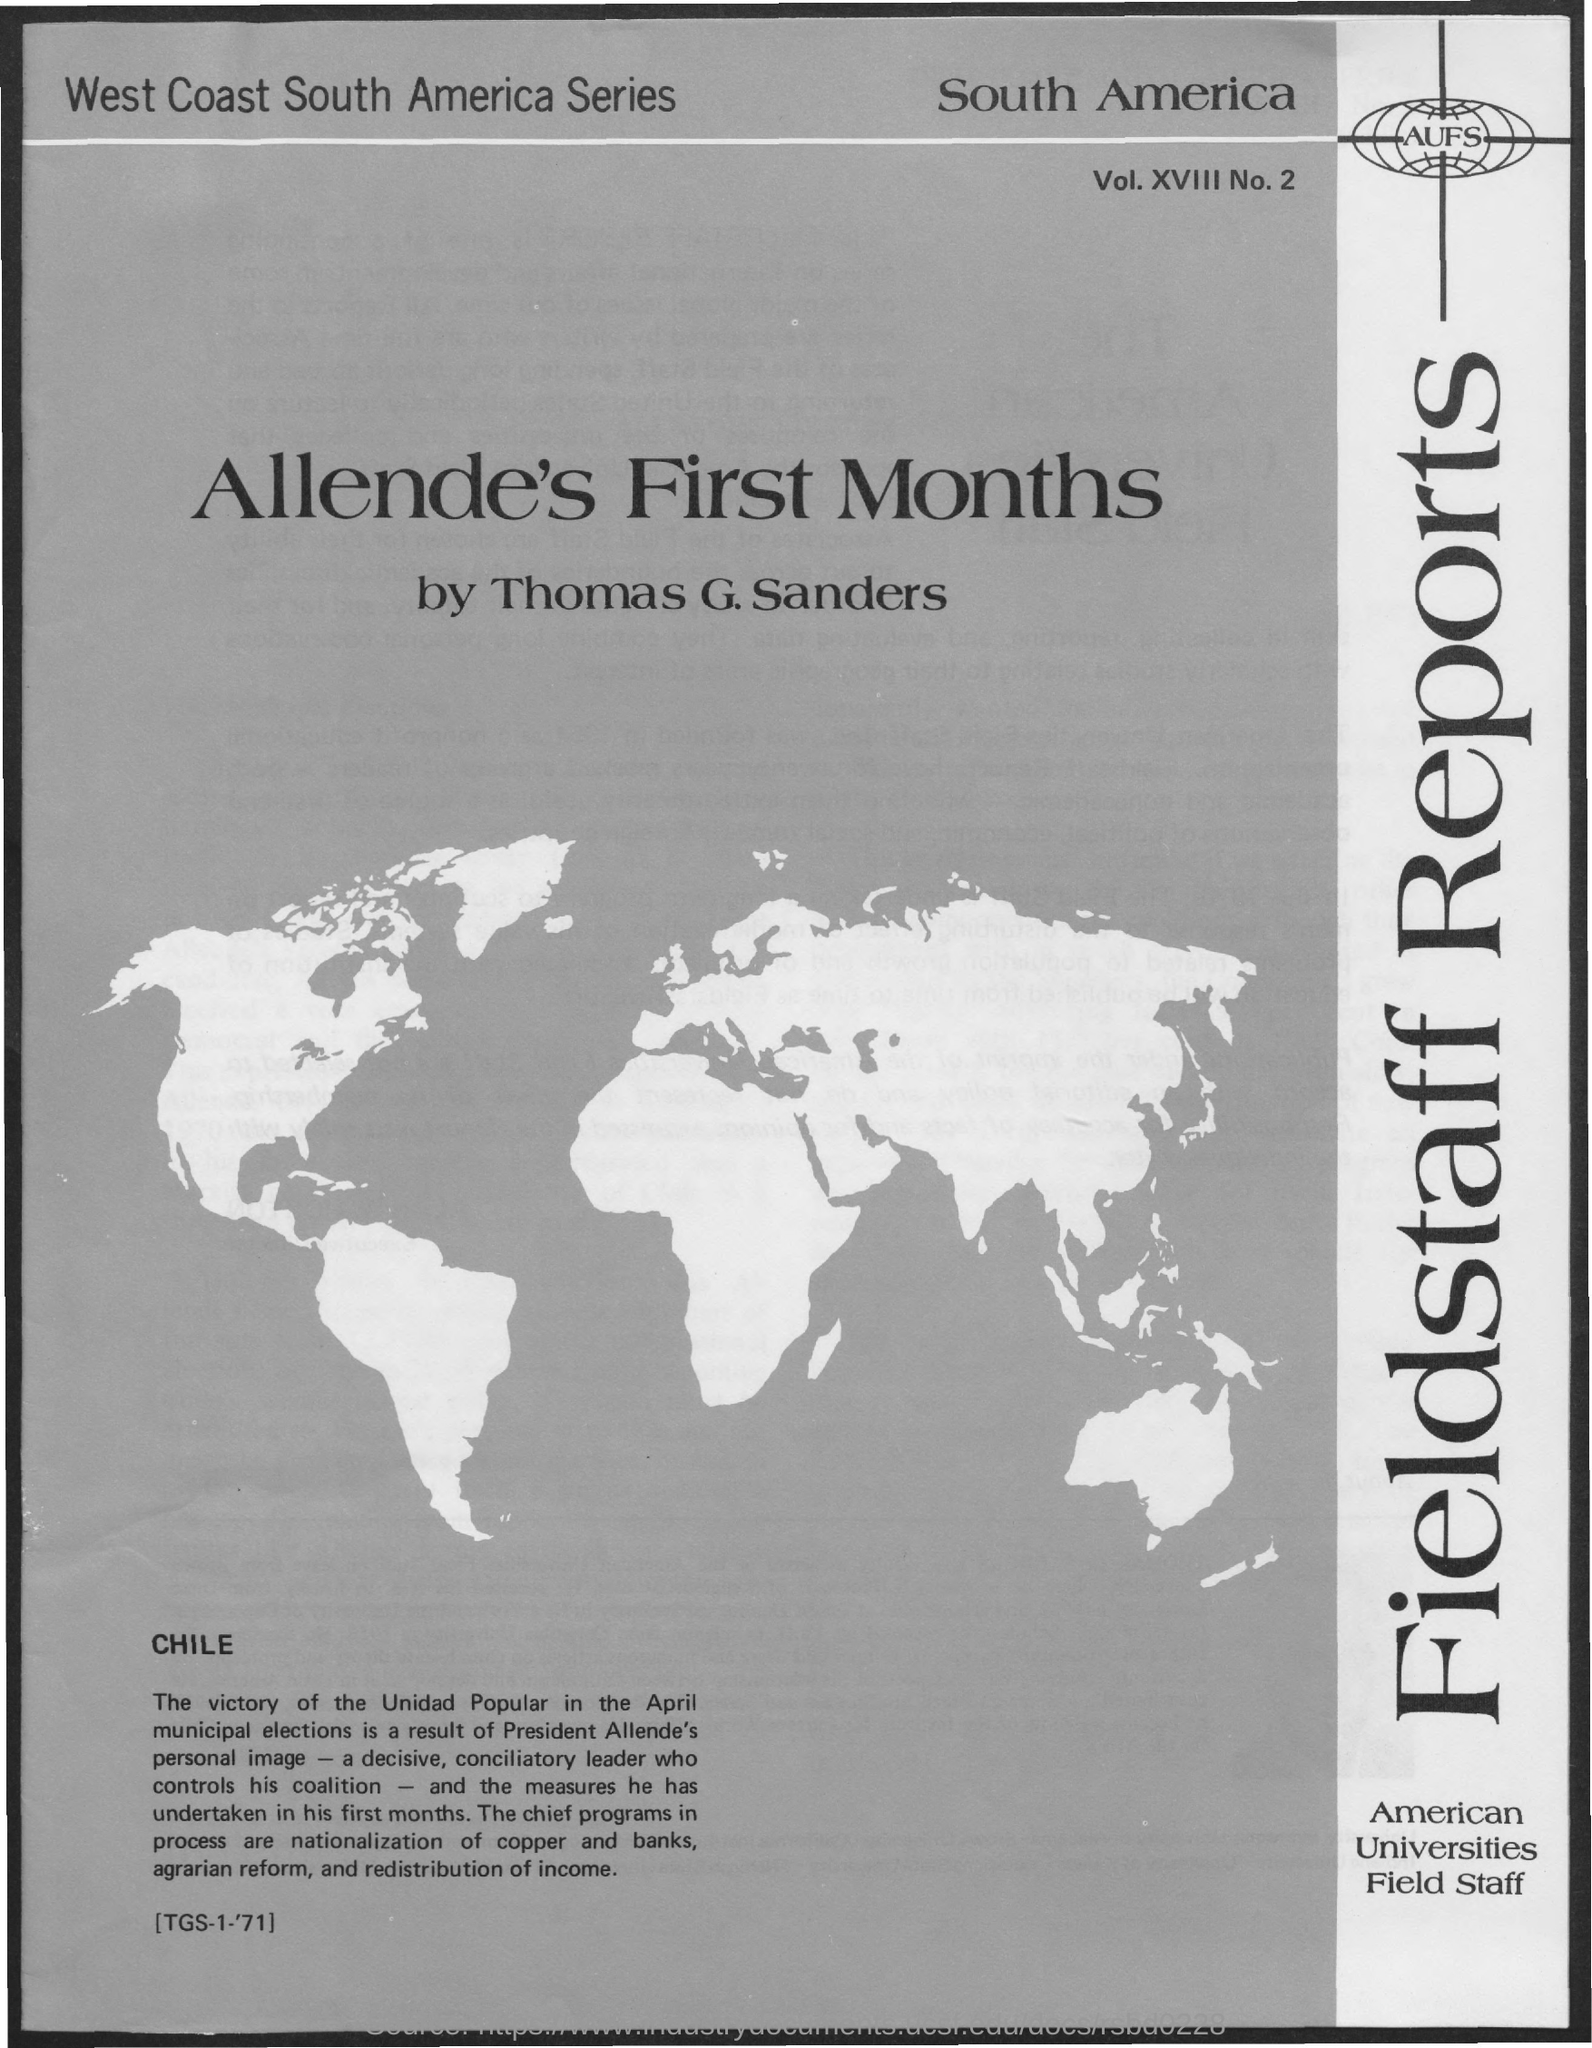Which text is inside the image?
Offer a terse response. AUFS. What is written at the top-left of the document?
Your answer should be compact. West coast south america series. What is the name of the country at the top-right of the document?
Ensure brevity in your answer.  South America. What is the volume number?
Ensure brevity in your answer.  Vol. xviii no. 2. 